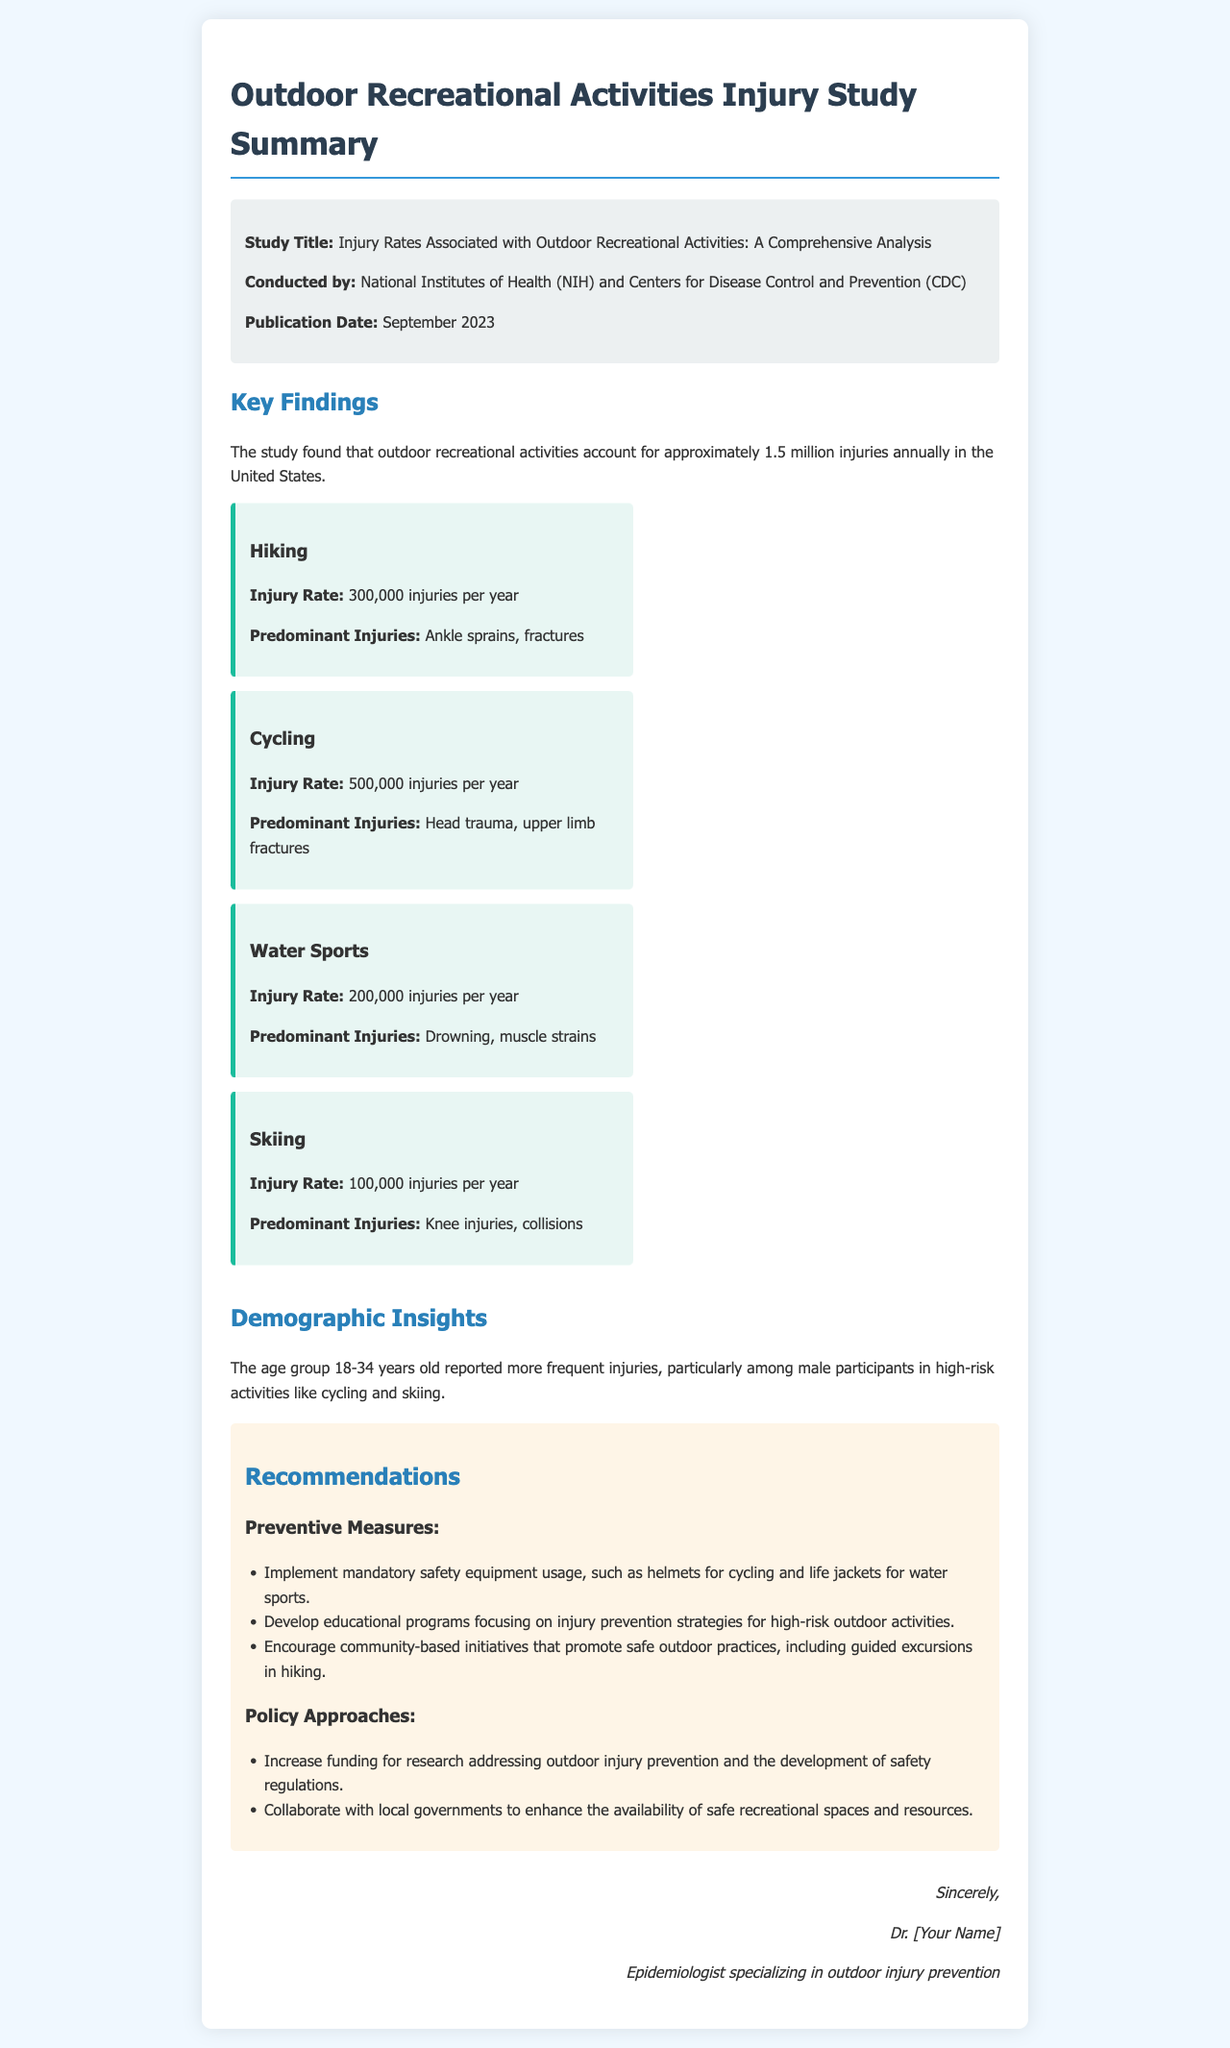What is the title of the study? The title of the study is listed in the document, which is "Injury Rates Associated with Outdoor Recreational Activities: A Comprehensive Analysis."
Answer: Injury Rates Associated with Outdoor Recreational Activities: A Comprehensive Analysis Who conducted the study? The document states that the study was conducted by the National Institutes of Health (NIH) and the Centers for Disease Control and Prevention (CDC).
Answer: National Institutes of Health (NIH) and Centers for Disease Control and Prevention (CDC) What month and year was the study published? The publication date of the study is mentioned in the document as September 2023.
Answer: September 2023 How many injuries are associated with cycling annually? The document provides specific injury statistics for cycling indicating that there are 500,000 injuries per year.
Answer: 500,000 injuries per year Which age group reported the most frequent injuries? The document indicates that the age group 18-34 years old reported more frequent injuries.
Answer: 18-34 years old What is one of the recommendations for preventive measures? The document provides a list of recommendations, one of which is to implement mandatory safety equipment usage.
Answer: Implement mandatory safety equipment usage What type of approach is suggested to enhance outdoor injury prevention? The document mentions policy approaches, one of which includes increasing funding for research addressing outdoor injury prevention.
Answer: Increase funding for research Which outdoor activity has the highest reported injury rate? The injury rates are specified in the document; cycling has the highest injury rate at 500,000 injuries per year.
Answer: Cycling What demographic showed a higher incidence of injuries in high-risk activities? The document notes that male participants in the age group 18-34 years showed higher incidences of injuries in high-risk activities.
Answer: Male participants 